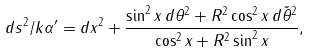<formula> <loc_0><loc_0><loc_500><loc_500>d s ^ { 2 } / k \alpha ^ { \prime } = d x ^ { 2 } + \frac { \sin ^ { 2 } x \, d \theta ^ { 2 } + R ^ { 2 } \cos ^ { 2 } x \, d \tilde { \theta } ^ { 2 } } { \cos ^ { 2 } x + R ^ { 2 } \sin ^ { 2 } x } ,</formula> 